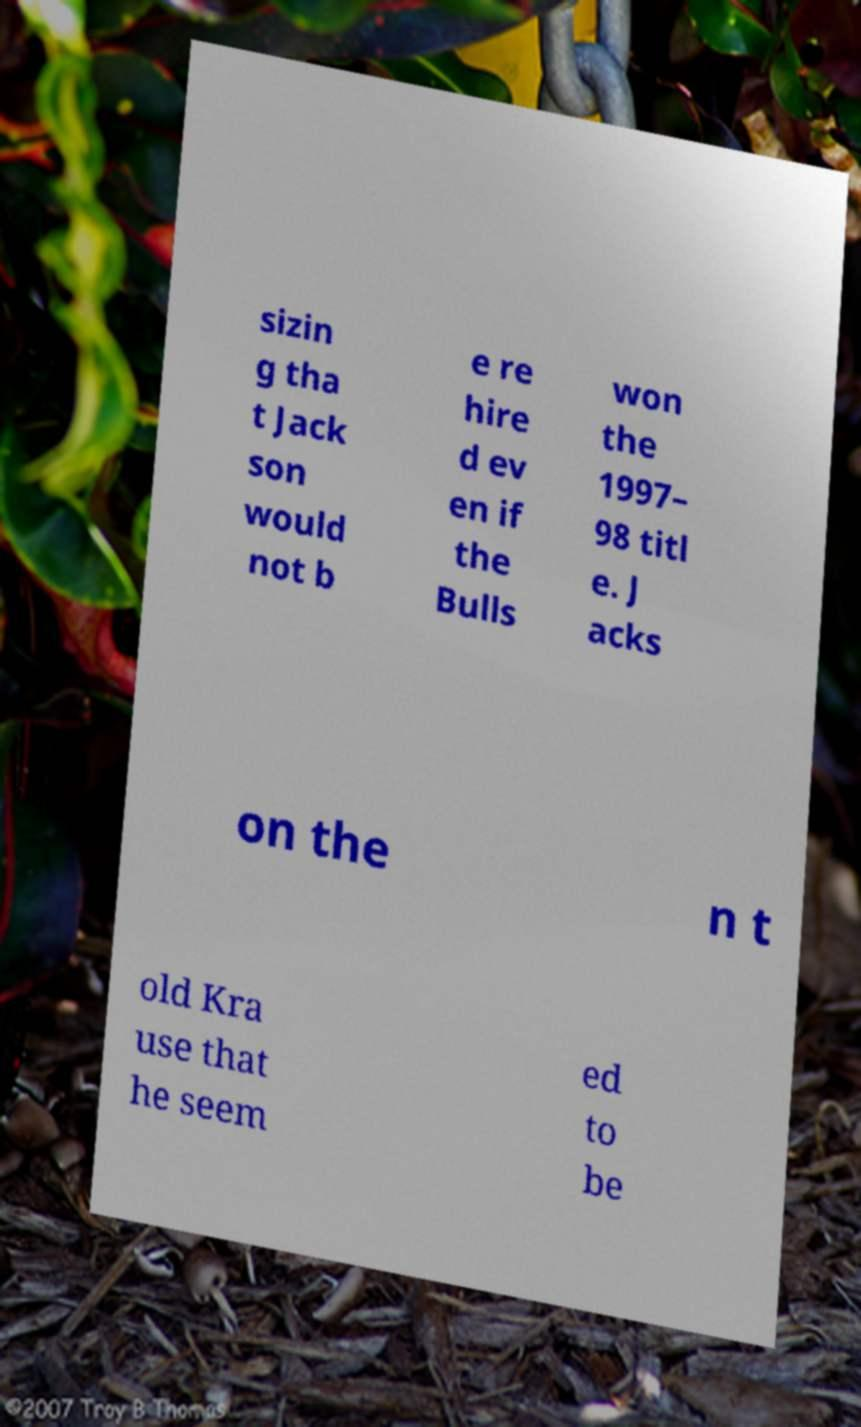Please read and relay the text visible in this image. What does it say? sizin g tha t Jack son would not b e re hire d ev en if the Bulls won the 1997– 98 titl e. J acks on the n t old Kra use that he seem ed to be 